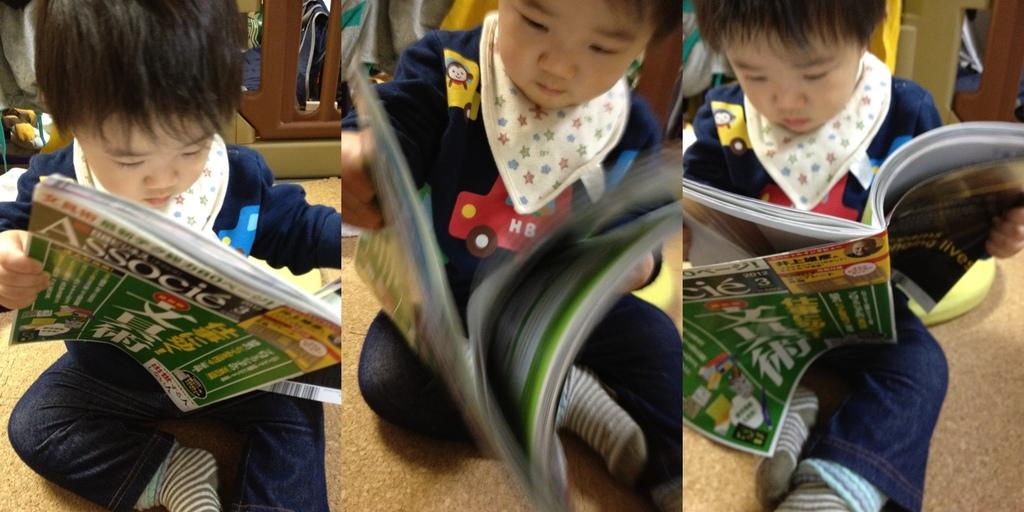What type of environment is depicted in the image? The image appears to be set in a college environment. Can you describe the person in the image? There is a child sitting in the image. What is the child doing in the image? The child is reading a book. What type of gate can be seen in the image? There is no gate present in the image. What offer is the child making to the ants in the image? There are no ants present in the image, and therefore no offer can be made. 